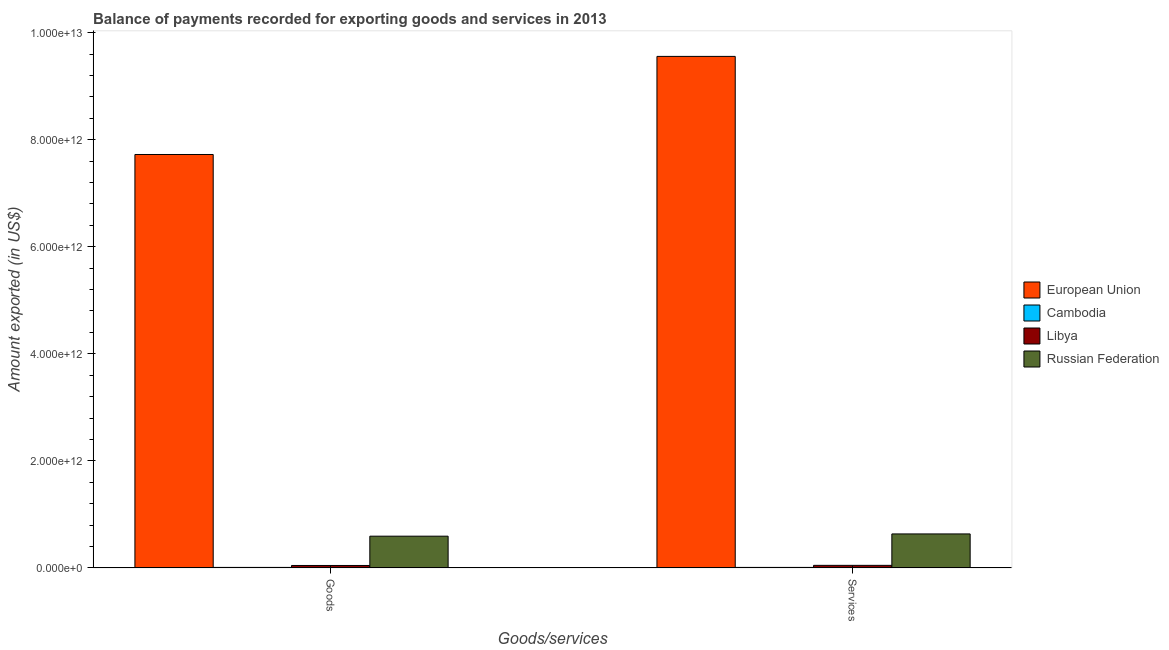How many different coloured bars are there?
Keep it short and to the point. 4. How many groups of bars are there?
Offer a very short reply. 2. Are the number of bars per tick equal to the number of legend labels?
Ensure brevity in your answer.  Yes. How many bars are there on the 2nd tick from the right?
Provide a short and direct response. 4. What is the label of the 2nd group of bars from the left?
Keep it short and to the point. Services. What is the amount of goods exported in European Union?
Your answer should be very brief. 7.72e+12. Across all countries, what is the maximum amount of services exported?
Your response must be concise. 9.56e+12. Across all countries, what is the minimum amount of services exported?
Offer a terse response. 1.01e+1. In which country was the amount of services exported maximum?
Offer a very short reply. European Union. In which country was the amount of services exported minimum?
Provide a short and direct response. Cambodia. What is the total amount of goods exported in the graph?
Your response must be concise. 8.37e+12. What is the difference between the amount of goods exported in Russian Federation and that in Cambodia?
Give a very brief answer. 5.83e+11. What is the difference between the amount of goods exported in Libya and the amount of services exported in European Union?
Keep it short and to the point. -9.51e+12. What is the average amount of goods exported per country?
Your answer should be compact. 2.09e+12. What is the difference between the amount of goods exported and amount of services exported in European Union?
Make the answer very short. -1.83e+12. What is the ratio of the amount of services exported in Russian Federation to that in Cambodia?
Your response must be concise. 63.01. What does the 2nd bar from the right in Goods represents?
Offer a terse response. Libya. Are all the bars in the graph horizontal?
Your answer should be very brief. No. How many countries are there in the graph?
Offer a terse response. 4. What is the difference between two consecutive major ticks on the Y-axis?
Offer a very short reply. 2.00e+12. Does the graph contain any zero values?
Give a very brief answer. No. Where does the legend appear in the graph?
Keep it short and to the point. Center right. What is the title of the graph?
Offer a terse response. Balance of payments recorded for exporting goods and services in 2013. What is the label or title of the X-axis?
Offer a terse response. Goods/services. What is the label or title of the Y-axis?
Your response must be concise. Amount exported (in US$). What is the Amount exported (in US$) in European Union in Goods?
Your answer should be compact. 7.72e+12. What is the Amount exported (in US$) in Cambodia in Goods?
Offer a terse response. 1.00e+1. What is the Amount exported (in US$) of Libya in Goods?
Keep it short and to the point. 4.62e+1. What is the Amount exported (in US$) of Russian Federation in Goods?
Keep it short and to the point. 5.93e+11. What is the Amount exported (in US$) of European Union in Services?
Provide a succinct answer. 9.56e+12. What is the Amount exported (in US$) of Cambodia in Services?
Your answer should be compact. 1.01e+1. What is the Amount exported (in US$) in Libya in Services?
Make the answer very short. 4.85e+1. What is the Amount exported (in US$) of Russian Federation in Services?
Make the answer very short. 6.36e+11. Across all Goods/services, what is the maximum Amount exported (in US$) of European Union?
Ensure brevity in your answer.  9.56e+12. Across all Goods/services, what is the maximum Amount exported (in US$) in Cambodia?
Provide a succinct answer. 1.01e+1. Across all Goods/services, what is the maximum Amount exported (in US$) of Libya?
Offer a very short reply. 4.85e+1. Across all Goods/services, what is the maximum Amount exported (in US$) of Russian Federation?
Offer a terse response. 6.36e+11. Across all Goods/services, what is the minimum Amount exported (in US$) of European Union?
Ensure brevity in your answer.  7.72e+12. Across all Goods/services, what is the minimum Amount exported (in US$) in Cambodia?
Keep it short and to the point. 1.00e+1. Across all Goods/services, what is the minimum Amount exported (in US$) in Libya?
Give a very brief answer. 4.62e+1. Across all Goods/services, what is the minimum Amount exported (in US$) of Russian Federation?
Provide a short and direct response. 5.93e+11. What is the total Amount exported (in US$) in European Union in the graph?
Offer a terse response. 1.73e+13. What is the total Amount exported (in US$) in Cambodia in the graph?
Offer a very short reply. 2.01e+1. What is the total Amount exported (in US$) in Libya in the graph?
Your answer should be compact. 9.47e+1. What is the total Amount exported (in US$) in Russian Federation in the graph?
Make the answer very short. 1.23e+12. What is the difference between the Amount exported (in US$) in European Union in Goods and that in Services?
Give a very brief answer. -1.83e+12. What is the difference between the Amount exported (in US$) of Cambodia in Goods and that in Services?
Your answer should be very brief. -7.08e+07. What is the difference between the Amount exported (in US$) in Libya in Goods and that in Services?
Make the answer very short. -2.28e+09. What is the difference between the Amount exported (in US$) of Russian Federation in Goods and that in Services?
Ensure brevity in your answer.  -4.22e+1. What is the difference between the Amount exported (in US$) of European Union in Goods and the Amount exported (in US$) of Cambodia in Services?
Provide a short and direct response. 7.71e+12. What is the difference between the Amount exported (in US$) in European Union in Goods and the Amount exported (in US$) in Libya in Services?
Make the answer very short. 7.68e+12. What is the difference between the Amount exported (in US$) of European Union in Goods and the Amount exported (in US$) of Russian Federation in Services?
Ensure brevity in your answer.  7.09e+12. What is the difference between the Amount exported (in US$) in Cambodia in Goods and the Amount exported (in US$) in Libya in Services?
Give a very brief answer. -3.85e+1. What is the difference between the Amount exported (in US$) in Cambodia in Goods and the Amount exported (in US$) in Russian Federation in Services?
Provide a short and direct response. -6.26e+11. What is the difference between the Amount exported (in US$) in Libya in Goods and the Amount exported (in US$) in Russian Federation in Services?
Provide a short and direct response. -5.89e+11. What is the average Amount exported (in US$) in European Union per Goods/services?
Provide a short and direct response. 8.64e+12. What is the average Amount exported (in US$) of Cambodia per Goods/services?
Your answer should be very brief. 1.01e+1. What is the average Amount exported (in US$) of Libya per Goods/services?
Offer a very short reply. 4.73e+1. What is the average Amount exported (in US$) of Russian Federation per Goods/services?
Your answer should be compact. 6.14e+11. What is the difference between the Amount exported (in US$) of European Union and Amount exported (in US$) of Cambodia in Goods?
Make the answer very short. 7.71e+12. What is the difference between the Amount exported (in US$) in European Union and Amount exported (in US$) in Libya in Goods?
Your answer should be compact. 7.68e+12. What is the difference between the Amount exported (in US$) in European Union and Amount exported (in US$) in Russian Federation in Goods?
Ensure brevity in your answer.  7.13e+12. What is the difference between the Amount exported (in US$) in Cambodia and Amount exported (in US$) in Libya in Goods?
Provide a succinct answer. -3.62e+1. What is the difference between the Amount exported (in US$) in Cambodia and Amount exported (in US$) in Russian Federation in Goods?
Offer a very short reply. -5.83e+11. What is the difference between the Amount exported (in US$) of Libya and Amount exported (in US$) of Russian Federation in Goods?
Ensure brevity in your answer.  -5.47e+11. What is the difference between the Amount exported (in US$) in European Union and Amount exported (in US$) in Cambodia in Services?
Your answer should be compact. 9.55e+12. What is the difference between the Amount exported (in US$) of European Union and Amount exported (in US$) of Libya in Services?
Keep it short and to the point. 9.51e+12. What is the difference between the Amount exported (in US$) in European Union and Amount exported (in US$) in Russian Federation in Services?
Provide a succinct answer. 8.92e+12. What is the difference between the Amount exported (in US$) of Cambodia and Amount exported (in US$) of Libya in Services?
Offer a very short reply. -3.84e+1. What is the difference between the Amount exported (in US$) in Cambodia and Amount exported (in US$) in Russian Federation in Services?
Offer a very short reply. -6.25e+11. What is the difference between the Amount exported (in US$) of Libya and Amount exported (in US$) of Russian Federation in Services?
Your response must be concise. -5.87e+11. What is the ratio of the Amount exported (in US$) of European Union in Goods to that in Services?
Offer a terse response. 0.81. What is the ratio of the Amount exported (in US$) of Libya in Goods to that in Services?
Offer a terse response. 0.95. What is the ratio of the Amount exported (in US$) of Russian Federation in Goods to that in Services?
Your answer should be very brief. 0.93. What is the difference between the highest and the second highest Amount exported (in US$) of European Union?
Offer a terse response. 1.83e+12. What is the difference between the highest and the second highest Amount exported (in US$) of Cambodia?
Ensure brevity in your answer.  7.08e+07. What is the difference between the highest and the second highest Amount exported (in US$) of Libya?
Ensure brevity in your answer.  2.28e+09. What is the difference between the highest and the second highest Amount exported (in US$) in Russian Federation?
Make the answer very short. 4.22e+1. What is the difference between the highest and the lowest Amount exported (in US$) in European Union?
Provide a succinct answer. 1.83e+12. What is the difference between the highest and the lowest Amount exported (in US$) in Cambodia?
Keep it short and to the point. 7.08e+07. What is the difference between the highest and the lowest Amount exported (in US$) in Libya?
Your response must be concise. 2.28e+09. What is the difference between the highest and the lowest Amount exported (in US$) in Russian Federation?
Keep it short and to the point. 4.22e+1. 